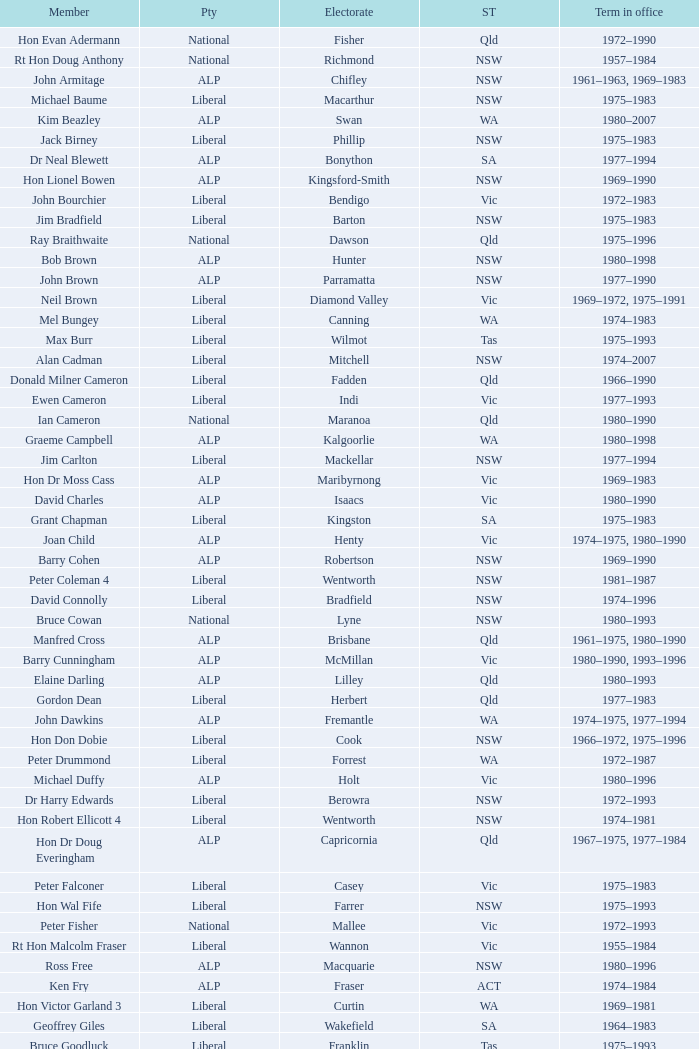To what party does Ralph Jacobi belong? ALP. 